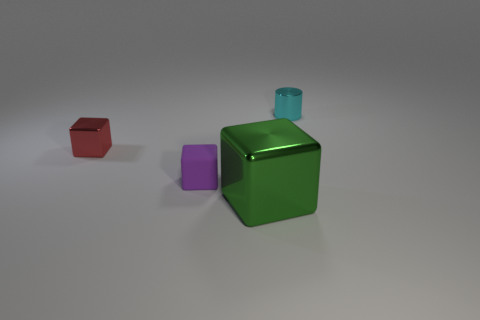Add 1 small shiny objects. How many objects exist? 5 Subtract all cylinders. How many objects are left? 3 Subtract 0 purple balls. How many objects are left? 4 Subtract all yellow matte cubes. Subtract all matte cubes. How many objects are left? 3 Add 3 big shiny blocks. How many big shiny blocks are left? 4 Add 4 small blocks. How many small blocks exist? 6 